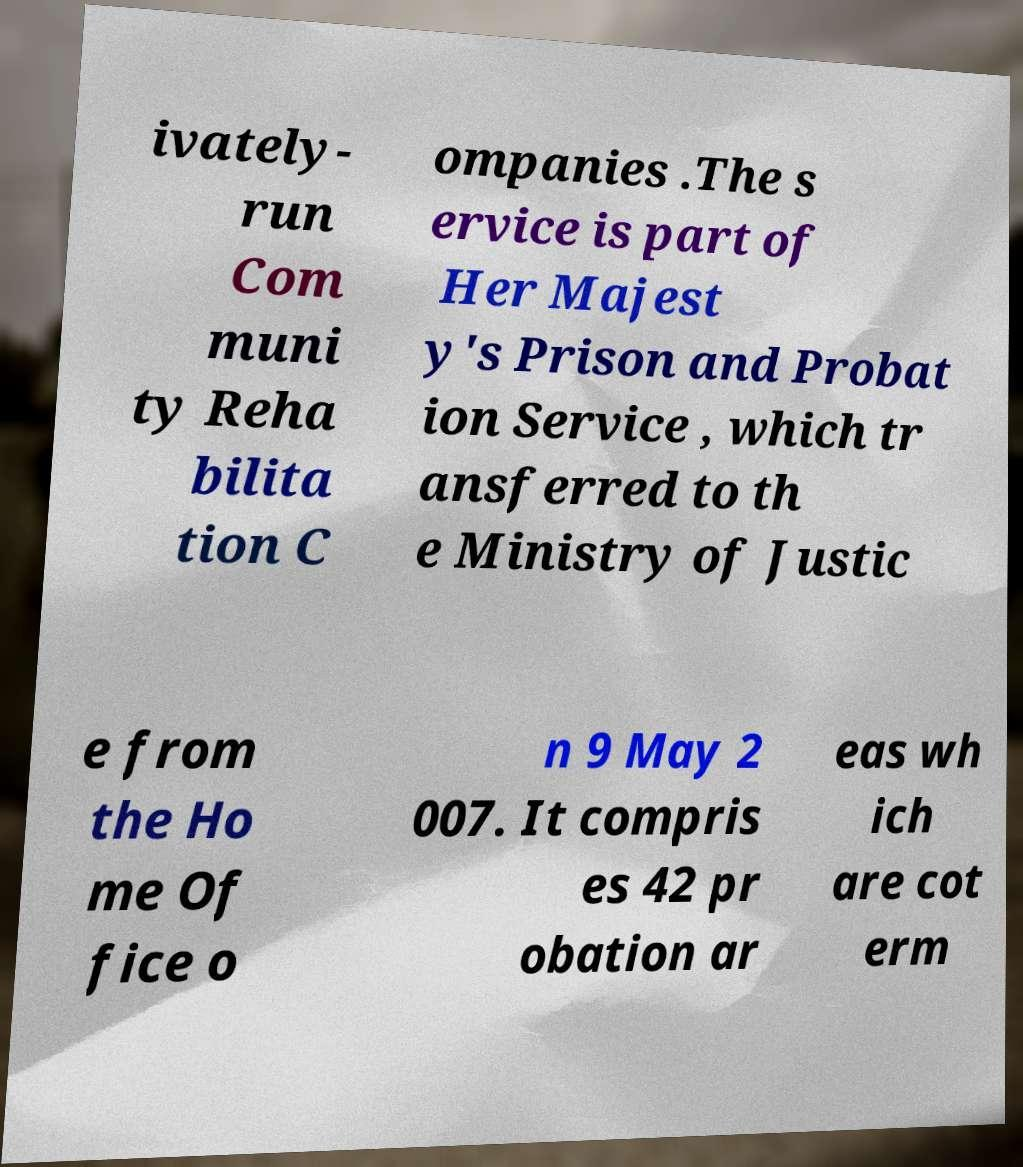Please identify and transcribe the text found in this image. ivately- run Com muni ty Reha bilita tion C ompanies .The s ervice is part of Her Majest y's Prison and Probat ion Service , which tr ansferred to th e Ministry of Justic e from the Ho me Of fice o n 9 May 2 007. It compris es 42 pr obation ar eas wh ich are cot erm 